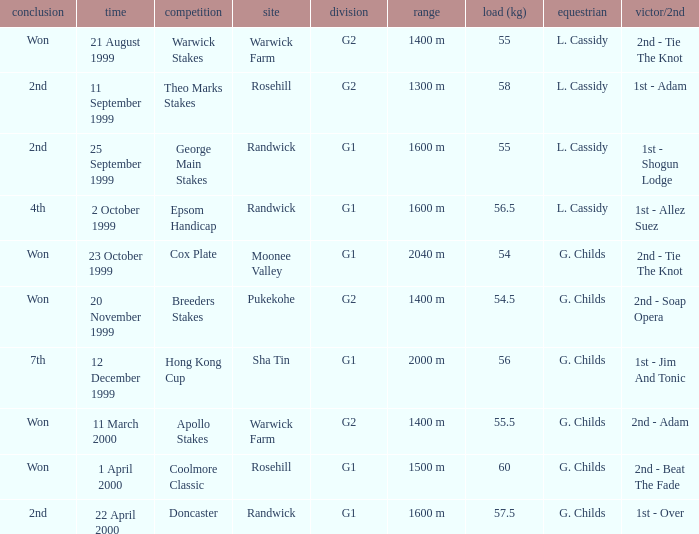List the weight for 56 kilograms. 2000 m. 